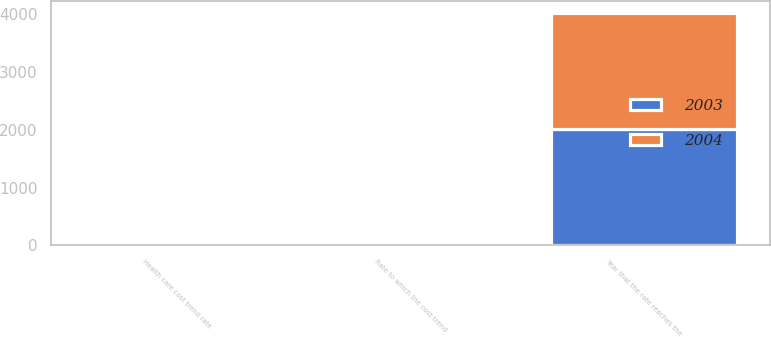<chart> <loc_0><loc_0><loc_500><loc_500><stacked_bar_chart><ecel><fcel>Health care cost trend rate<fcel>Rate to which the cost trend<fcel>Year that the rate reaches the<nl><fcel>2003<fcel>9<fcel>5<fcel>2012<nl><fcel>2004<fcel>9.5<fcel>5<fcel>2012<nl></chart> 